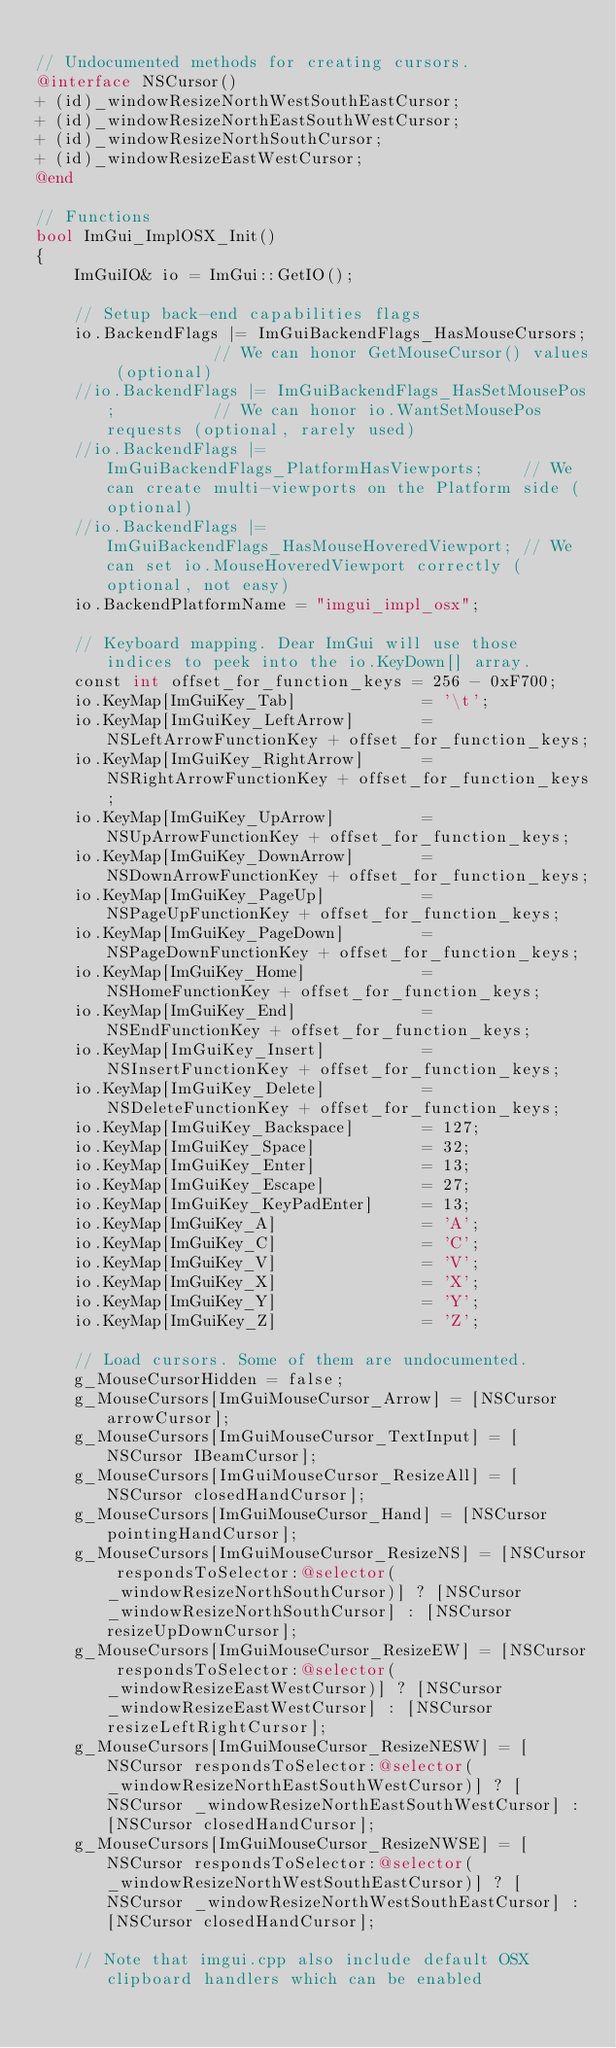Convert code to text. <code><loc_0><loc_0><loc_500><loc_500><_ObjectiveC_>
// Undocumented methods for creating cursors.
@interface NSCursor()
+ (id)_windowResizeNorthWestSouthEastCursor;
+ (id)_windowResizeNorthEastSouthWestCursor;
+ (id)_windowResizeNorthSouthCursor;
+ (id)_windowResizeEastWestCursor;
@end

// Functions
bool ImGui_ImplOSX_Init()
{
    ImGuiIO& io = ImGui::GetIO();

    // Setup back-end capabilities flags
    io.BackendFlags |= ImGuiBackendFlags_HasMouseCursors;           // We can honor GetMouseCursor() values (optional)
    //io.BackendFlags |= ImGuiBackendFlags_HasSetMousePos;          // We can honor io.WantSetMousePos requests (optional, rarely used)
    //io.BackendFlags |= ImGuiBackendFlags_PlatformHasViewports;    // We can create multi-viewports on the Platform side (optional)
    //io.BackendFlags |= ImGuiBackendFlags_HasMouseHoveredViewport; // We can set io.MouseHoveredViewport correctly (optional, not easy)
    io.BackendPlatformName = "imgui_impl_osx";

    // Keyboard mapping. Dear ImGui will use those indices to peek into the io.KeyDown[] array.
    const int offset_for_function_keys = 256 - 0xF700;
    io.KeyMap[ImGuiKey_Tab]             = '\t';
    io.KeyMap[ImGuiKey_LeftArrow]       = NSLeftArrowFunctionKey + offset_for_function_keys;
    io.KeyMap[ImGuiKey_RightArrow]      = NSRightArrowFunctionKey + offset_for_function_keys;
    io.KeyMap[ImGuiKey_UpArrow]         = NSUpArrowFunctionKey + offset_for_function_keys;
    io.KeyMap[ImGuiKey_DownArrow]       = NSDownArrowFunctionKey + offset_for_function_keys;
    io.KeyMap[ImGuiKey_PageUp]          = NSPageUpFunctionKey + offset_for_function_keys;
    io.KeyMap[ImGuiKey_PageDown]        = NSPageDownFunctionKey + offset_for_function_keys;
    io.KeyMap[ImGuiKey_Home]            = NSHomeFunctionKey + offset_for_function_keys;
    io.KeyMap[ImGuiKey_End]             = NSEndFunctionKey + offset_for_function_keys;
    io.KeyMap[ImGuiKey_Insert]          = NSInsertFunctionKey + offset_for_function_keys;
    io.KeyMap[ImGuiKey_Delete]          = NSDeleteFunctionKey + offset_for_function_keys;
    io.KeyMap[ImGuiKey_Backspace]       = 127;
    io.KeyMap[ImGuiKey_Space]           = 32;
    io.KeyMap[ImGuiKey_Enter]           = 13;
    io.KeyMap[ImGuiKey_Escape]          = 27;
    io.KeyMap[ImGuiKey_KeyPadEnter]     = 13;
    io.KeyMap[ImGuiKey_A]               = 'A';
    io.KeyMap[ImGuiKey_C]               = 'C';
    io.KeyMap[ImGuiKey_V]               = 'V';
    io.KeyMap[ImGuiKey_X]               = 'X';
    io.KeyMap[ImGuiKey_Y]               = 'Y';
    io.KeyMap[ImGuiKey_Z]               = 'Z';

    // Load cursors. Some of them are undocumented.
    g_MouseCursorHidden = false;
    g_MouseCursors[ImGuiMouseCursor_Arrow] = [NSCursor arrowCursor];
    g_MouseCursors[ImGuiMouseCursor_TextInput] = [NSCursor IBeamCursor];
    g_MouseCursors[ImGuiMouseCursor_ResizeAll] = [NSCursor closedHandCursor];
    g_MouseCursors[ImGuiMouseCursor_Hand] = [NSCursor pointingHandCursor];
    g_MouseCursors[ImGuiMouseCursor_ResizeNS] = [NSCursor respondsToSelector:@selector(_windowResizeNorthSouthCursor)] ? [NSCursor _windowResizeNorthSouthCursor] : [NSCursor resizeUpDownCursor];
    g_MouseCursors[ImGuiMouseCursor_ResizeEW] = [NSCursor respondsToSelector:@selector(_windowResizeEastWestCursor)] ? [NSCursor _windowResizeEastWestCursor] : [NSCursor resizeLeftRightCursor];
    g_MouseCursors[ImGuiMouseCursor_ResizeNESW] = [NSCursor respondsToSelector:@selector(_windowResizeNorthEastSouthWestCursor)] ? [NSCursor _windowResizeNorthEastSouthWestCursor] : [NSCursor closedHandCursor];
    g_MouseCursors[ImGuiMouseCursor_ResizeNWSE] = [NSCursor respondsToSelector:@selector(_windowResizeNorthWestSouthEastCursor)] ? [NSCursor _windowResizeNorthWestSouthEastCursor] : [NSCursor closedHandCursor];

    // Note that imgui.cpp also include default OSX clipboard handlers which can be enabled</code> 